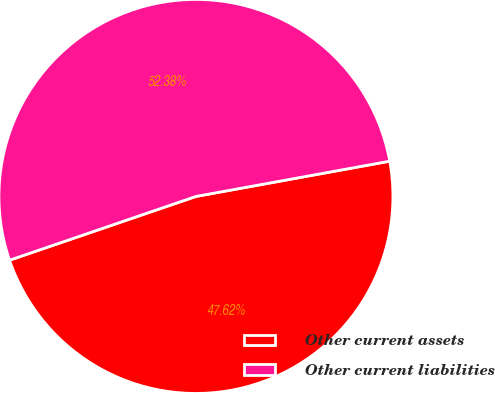<chart> <loc_0><loc_0><loc_500><loc_500><pie_chart><fcel>Other current assets<fcel>Other current liabilities<nl><fcel>47.62%<fcel>52.38%<nl></chart> 